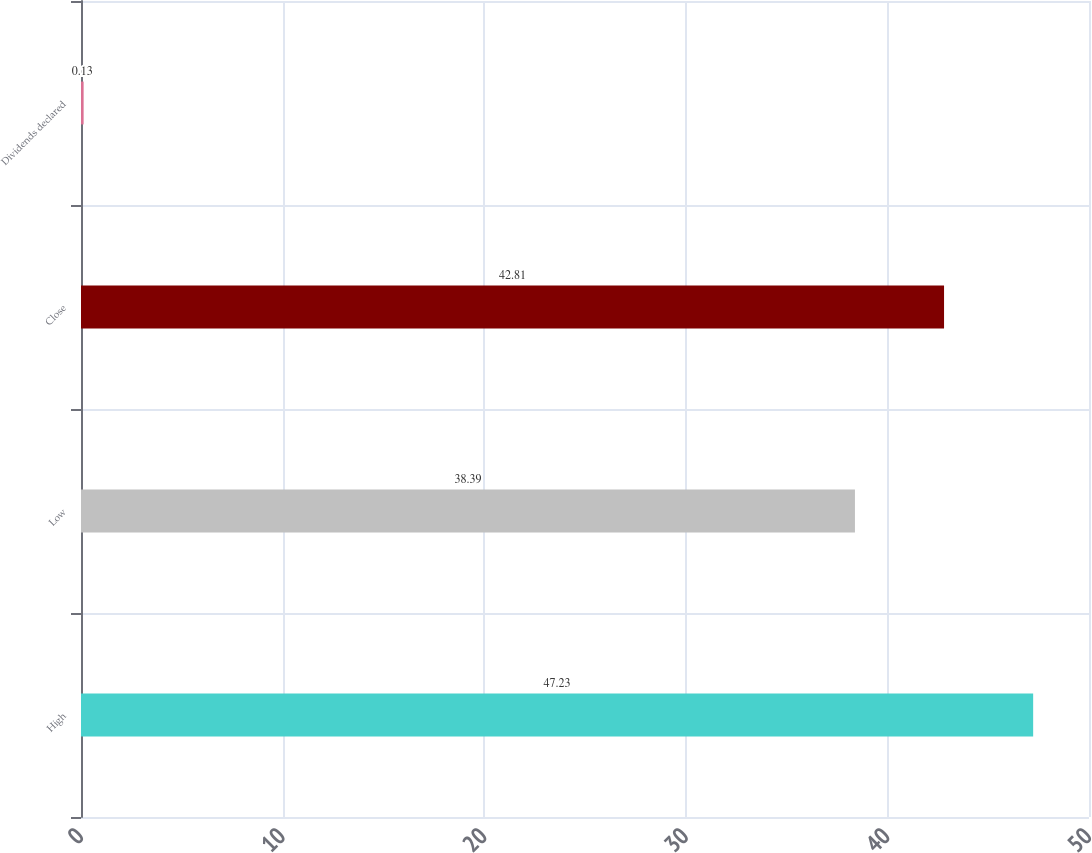Convert chart. <chart><loc_0><loc_0><loc_500><loc_500><bar_chart><fcel>High<fcel>Low<fcel>Close<fcel>Dividends declared<nl><fcel>47.23<fcel>38.39<fcel>42.81<fcel>0.13<nl></chart> 